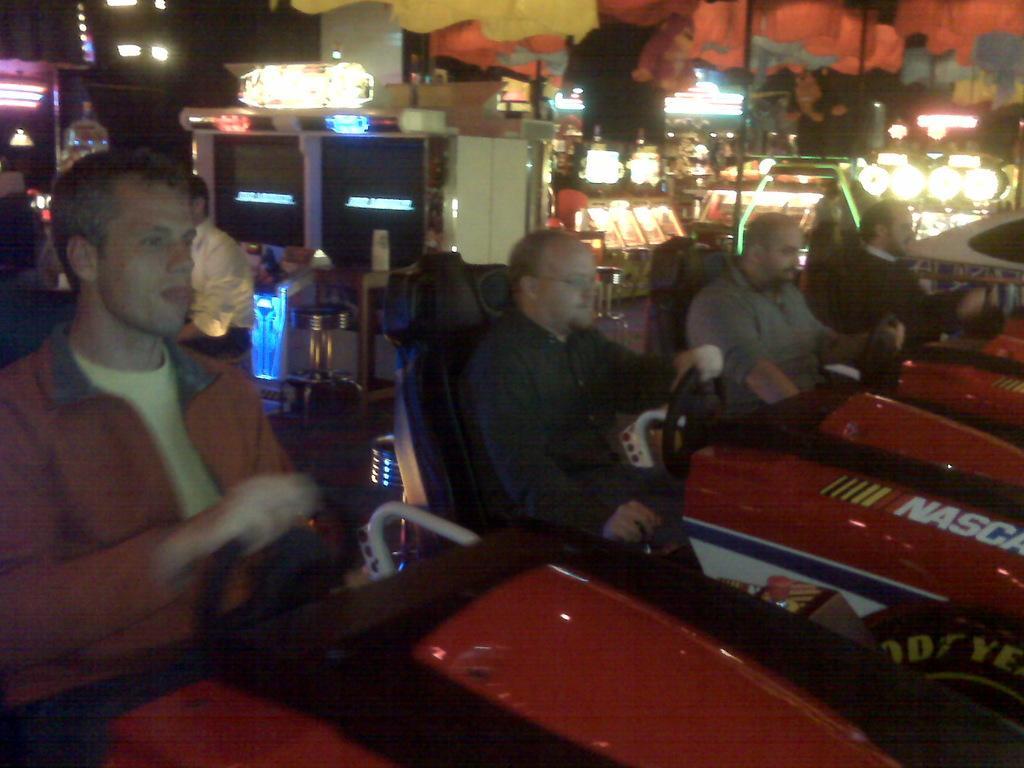Could you give a brief overview of what you see in this image? In this image, we can see few people are sitting on the seats and playing games. Background we can see screens, some objects, lights, rods. Top of the image, we can see orange and yellow color objects. 